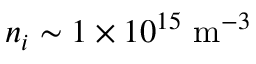<formula> <loc_0><loc_0><loc_500><loc_500>n _ { i } \sim 1 \times 1 0 ^ { 1 5 } m ^ { - 3 }</formula> 